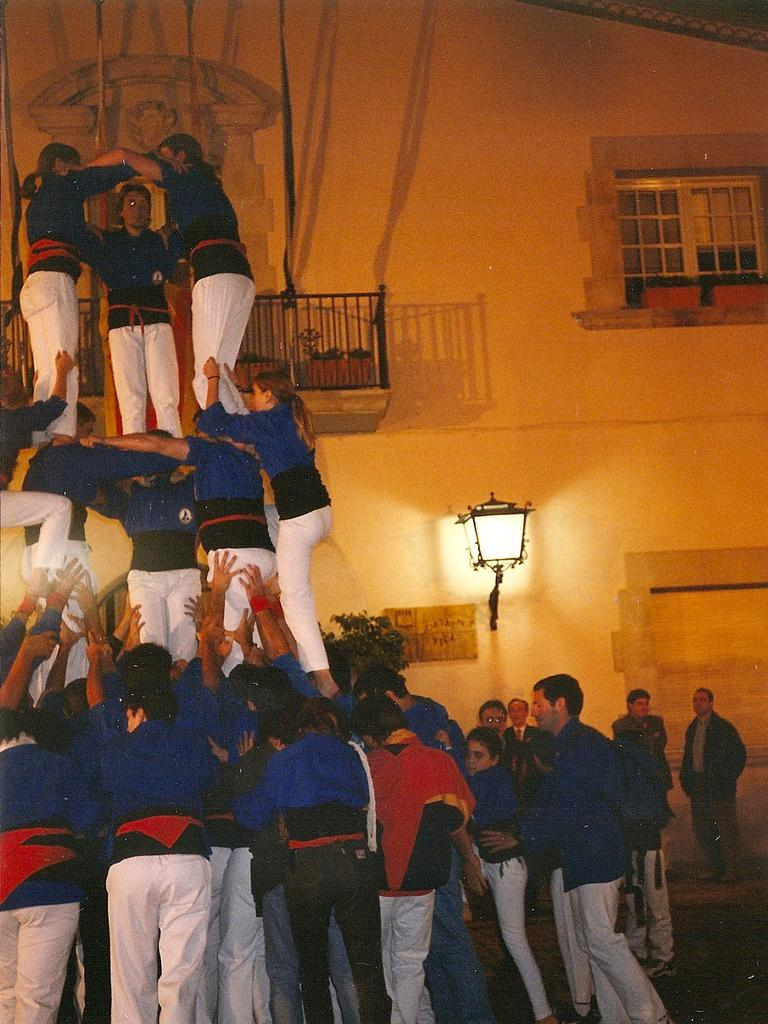What activity are the people in the image engaged in? The people in the image are performing circus acts. What can be seen in the background of the image? There is a building in the background of the image. What feature of the building is mentioned in the facts? The building has windows. Can you describe another object in the image? There is a lamp in the image. What type of drug is being sold in the image? There is no indication of any drug being sold or present in the image. Can you describe the amusement park in the image? There is no amusement park mentioned in the image; it features a circus performance with a building and a lamp in the background. 